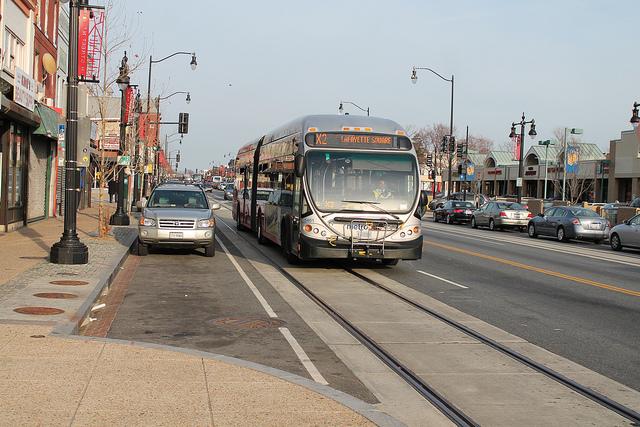What color are the lamp posts?
Short answer required. Black. Are the sidewalks crowded?
Quick response, please. No. Where is the bus going?
Be succinct. Square. 